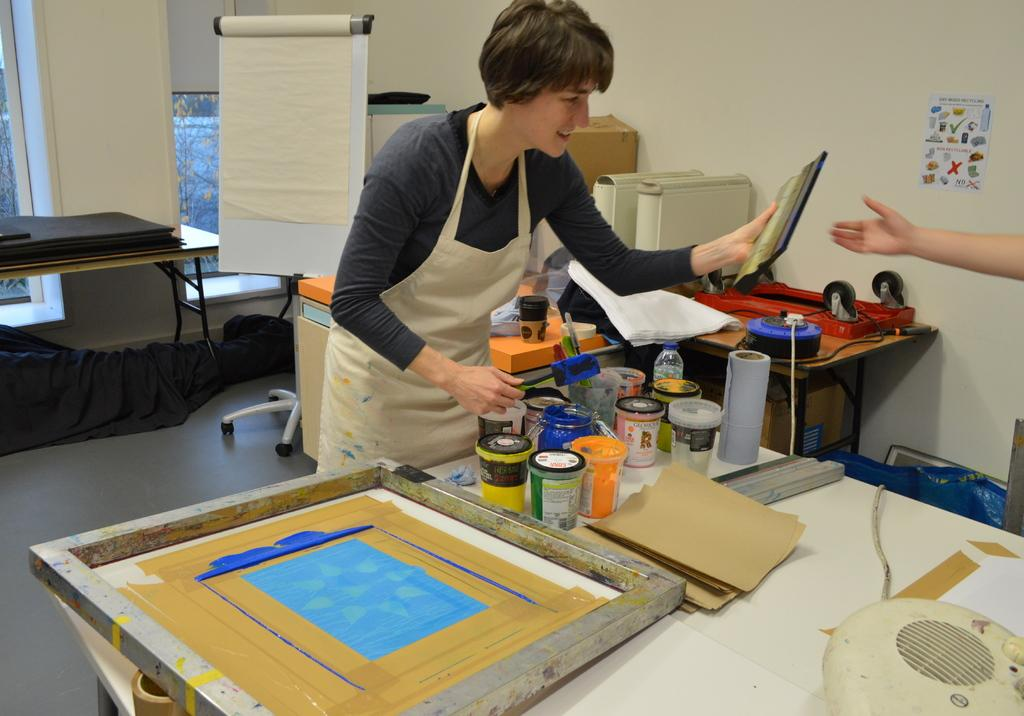What is the main subject of the image? There is a woman standing in the image. Where is the woman standing? The woman is standing on the floor. What is in front of the woman? There is a table in front of the woman. What items can be seen on the table? There are bottles and tissue on the table. What color is the wall in the background? The wall in the background is cream-colored. What type of pancake is being served on the table in the image? There is no pancake present in the image; the table has bottles and tissue on it. What hobbies does the woman in the image enjoy during winter? The image does not provide information about the woman's hobbies or the season, so we cannot determine her winter hobbies from the image. 